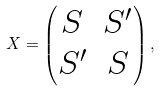<formula> <loc_0><loc_0><loc_500><loc_500>X = \begin{pmatrix} S & S ^ { \prime } \\ S ^ { \prime } & S \\ \end{pmatrix} ,</formula> 